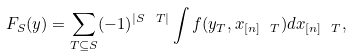<formula> <loc_0><loc_0><loc_500><loc_500>F _ { S } ( y ) = \sum _ { T \subseteq S } ( - 1 ) ^ { | S \ T | } \int f ( y _ { T } , x _ { [ n ] \ T } ) d x _ { [ n ] \ T } ,</formula> 